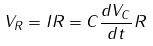<formula> <loc_0><loc_0><loc_500><loc_500>V _ { R } = I R = C \frac { d V _ { C } } { d t } R</formula> 